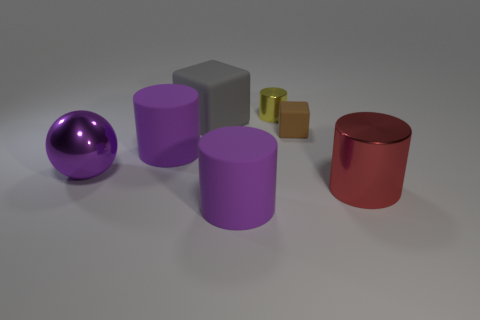Add 2 big yellow spheres. How many objects exist? 9 Subtract all cubes. How many objects are left? 5 Add 2 tiny brown blocks. How many tiny brown blocks are left? 3 Add 4 metal cylinders. How many metal cylinders exist? 6 Subtract 0 green balls. How many objects are left? 7 Subtract all big purple rubber objects. Subtract all large rubber cylinders. How many objects are left? 3 